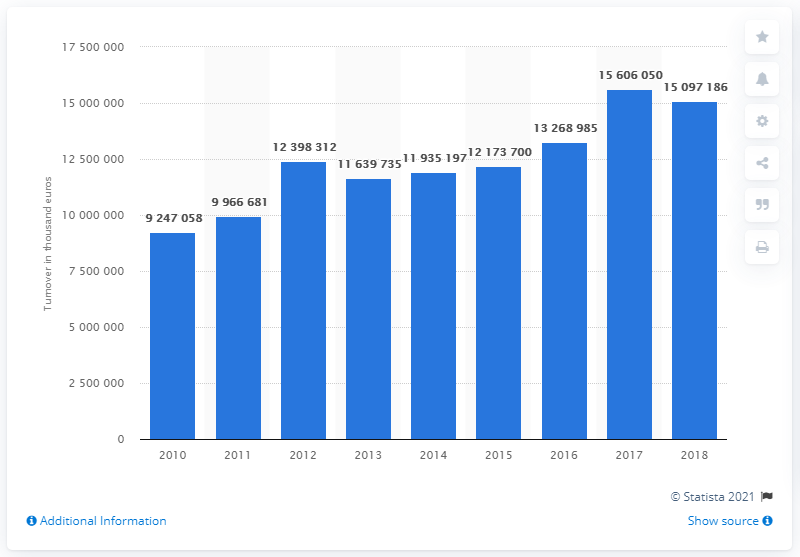Identify some key points in this picture. In 2018, there was a significant increase in gambling and betting activity in Italy. 